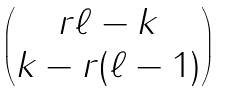Convert formula to latex. <formula><loc_0><loc_0><loc_500><loc_500>\begin{pmatrix} r \ell - k \\ k - r ( \ell - 1 ) \end{pmatrix}</formula> 